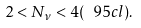<formula> <loc_0><loc_0><loc_500><loc_500>2 < N _ { \nu } < 4 ( \ 9 5 c l ) .</formula> 